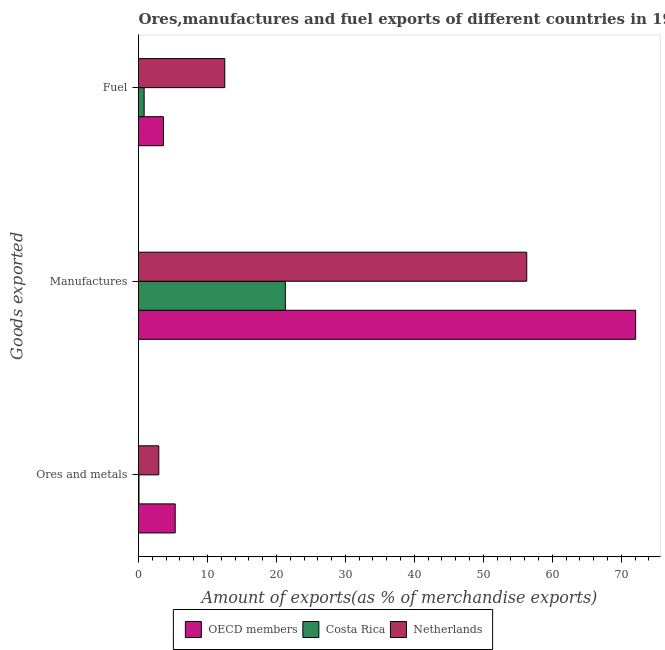How many groups of bars are there?
Offer a very short reply. 3. Are the number of bars on each tick of the Y-axis equal?
Keep it short and to the point. Yes. How many bars are there on the 3rd tick from the top?
Your response must be concise. 3. How many bars are there on the 1st tick from the bottom?
Your answer should be very brief. 3. What is the label of the 1st group of bars from the top?
Make the answer very short. Fuel. What is the percentage of ores and metals exports in Costa Rica?
Ensure brevity in your answer.  0.07. Across all countries, what is the maximum percentage of fuel exports?
Make the answer very short. 12.51. Across all countries, what is the minimum percentage of manufactures exports?
Keep it short and to the point. 21.29. In which country was the percentage of fuel exports minimum?
Your answer should be very brief. Costa Rica. What is the total percentage of manufactures exports in the graph?
Ensure brevity in your answer.  149.67. What is the difference between the percentage of fuel exports in Netherlands and that in Costa Rica?
Keep it short and to the point. 11.69. What is the difference between the percentage of fuel exports in Netherlands and the percentage of manufactures exports in Costa Rica?
Offer a very short reply. -8.78. What is the average percentage of manufactures exports per country?
Offer a terse response. 49.89. What is the difference between the percentage of manufactures exports and percentage of fuel exports in Netherlands?
Make the answer very short. 43.79. What is the ratio of the percentage of manufactures exports in OECD members to that in Netherlands?
Ensure brevity in your answer.  1.28. Is the difference between the percentage of fuel exports in Netherlands and Costa Rica greater than the difference between the percentage of manufactures exports in Netherlands and Costa Rica?
Your answer should be compact. No. What is the difference between the highest and the second highest percentage of fuel exports?
Offer a terse response. 8.9. What is the difference between the highest and the lowest percentage of fuel exports?
Offer a terse response. 11.69. What does the 3rd bar from the bottom in Manufactures represents?
Your answer should be compact. Netherlands. Is it the case that in every country, the sum of the percentage of ores and metals exports and percentage of manufactures exports is greater than the percentage of fuel exports?
Offer a terse response. Yes. Are all the bars in the graph horizontal?
Offer a very short reply. Yes. How many countries are there in the graph?
Make the answer very short. 3. Does the graph contain grids?
Give a very brief answer. No. How are the legend labels stacked?
Keep it short and to the point. Horizontal. What is the title of the graph?
Offer a terse response. Ores,manufactures and fuel exports of different countries in 1971. What is the label or title of the X-axis?
Provide a succinct answer. Amount of exports(as % of merchandise exports). What is the label or title of the Y-axis?
Ensure brevity in your answer.  Goods exported. What is the Amount of exports(as % of merchandise exports) of OECD members in Ores and metals?
Your response must be concise. 5.32. What is the Amount of exports(as % of merchandise exports) of Costa Rica in Ores and metals?
Give a very brief answer. 0.07. What is the Amount of exports(as % of merchandise exports) in Netherlands in Ores and metals?
Provide a succinct answer. 2.94. What is the Amount of exports(as % of merchandise exports) of OECD members in Manufactures?
Offer a very short reply. 72.08. What is the Amount of exports(as % of merchandise exports) in Costa Rica in Manufactures?
Keep it short and to the point. 21.29. What is the Amount of exports(as % of merchandise exports) of Netherlands in Manufactures?
Offer a very short reply. 56.29. What is the Amount of exports(as % of merchandise exports) in OECD members in Fuel?
Make the answer very short. 3.61. What is the Amount of exports(as % of merchandise exports) of Costa Rica in Fuel?
Provide a succinct answer. 0.82. What is the Amount of exports(as % of merchandise exports) of Netherlands in Fuel?
Make the answer very short. 12.51. Across all Goods exported, what is the maximum Amount of exports(as % of merchandise exports) of OECD members?
Provide a succinct answer. 72.08. Across all Goods exported, what is the maximum Amount of exports(as % of merchandise exports) in Costa Rica?
Your answer should be compact. 21.29. Across all Goods exported, what is the maximum Amount of exports(as % of merchandise exports) in Netherlands?
Provide a succinct answer. 56.29. Across all Goods exported, what is the minimum Amount of exports(as % of merchandise exports) in OECD members?
Your answer should be very brief. 3.61. Across all Goods exported, what is the minimum Amount of exports(as % of merchandise exports) in Costa Rica?
Give a very brief answer. 0.07. Across all Goods exported, what is the minimum Amount of exports(as % of merchandise exports) of Netherlands?
Keep it short and to the point. 2.94. What is the total Amount of exports(as % of merchandise exports) of OECD members in the graph?
Offer a terse response. 81.01. What is the total Amount of exports(as % of merchandise exports) in Costa Rica in the graph?
Your answer should be compact. 22.17. What is the total Amount of exports(as % of merchandise exports) in Netherlands in the graph?
Your response must be concise. 71.74. What is the difference between the Amount of exports(as % of merchandise exports) in OECD members in Ores and metals and that in Manufactures?
Your answer should be very brief. -66.76. What is the difference between the Amount of exports(as % of merchandise exports) of Costa Rica in Ores and metals and that in Manufactures?
Ensure brevity in your answer.  -21.22. What is the difference between the Amount of exports(as % of merchandise exports) of Netherlands in Ores and metals and that in Manufactures?
Your answer should be compact. -53.35. What is the difference between the Amount of exports(as % of merchandise exports) of OECD members in Ores and metals and that in Fuel?
Ensure brevity in your answer.  1.71. What is the difference between the Amount of exports(as % of merchandise exports) of Costa Rica in Ores and metals and that in Fuel?
Ensure brevity in your answer.  -0.75. What is the difference between the Amount of exports(as % of merchandise exports) in Netherlands in Ores and metals and that in Fuel?
Your answer should be very brief. -9.56. What is the difference between the Amount of exports(as % of merchandise exports) in OECD members in Manufactures and that in Fuel?
Offer a terse response. 68.47. What is the difference between the Amount of exports(as % of merchandise exports) of Costa Rica in Manufactures and that in Fuel?
Provide a succinct answer. 20.47. What is the difference between the Amount of exports(as % of merchandise exports) in Netherlands in Manufactures and that in Fuel?
Keep it short and to the point. 43.79. What is the difference between the Amount of exports(as % of merchandise exports) in OECD members in Ores and metals and the Amount of exports(as % of merchandise exports) in Costa Rica in Manufactures?
Make the answer very short. -15.97. What is the difference between the Amount of exports(as % of merchandise exports) in OECD members in Ores and metals and the Amount of exports(as % of merchandise exports) in Netherlands in Manufactures?
Give a very brief answer. -50.97. What is the difference between the Amount of exports(as % of merchandise exports) of Costa Rica in Ores and metals and the Amount of exports(as % of merchandise exports) of Netherlands in Manufactures?
Your answer should be very brief. -56.23. What is the difference between the Amount of exports(as % of merchandise exports) of OECD members in Ores and metals and the Amount of exports(as % of merchandise exports) of Costa Rica in Fuel?
Keep it short and to the point. 4.5. What is the difference between the Amount of exports(as % of merchandise exports) of OECD members in Ores and metals and the Amount of exports(as % of merchandise exports) of Netherlands in Fuel?
Provide a succinct answer. -7.19. What is the difference between the Amount of exports(as % of merchandise exports) of Costa Rica in Ores and metals and the Amount of exports(as % of merchandise exports) of Netherlands in Fuel?
Offer a terse response. -12.44. What is the difference between the Amount of exports(as % of merchandise exports) in OECD members in Manufactures and the Amount of exports(as % of merchandise exports) in Costa Rica in Fuel?
Offer a terse response. 71.27. What is the difference between the Amount of exports(as % of merchandise exports) of OECD members in Manufactures and the Amount of exports(as % of merchandise exports) of Netherlands in Fuel?
Give a very brief answer. 59.58. What is the difference between the Amount of exports(as % of merchandise exports) in Costa Rica in Manufactures and the Amount of exports(as % of merchandise exports) in Netherlands in Fuel?
Provide a short and direct response. 8.78. What is the average Amount of exports(as % of merchandise exports) in OECD members per Goods exported?
Provide a succinct answer. 27. What is the average Amount of exports(as % of merchandise exports) of Costa Rica per Goods exported?
Offer a very short reply. 7.39. What is the average Amount of exports(as % of merchandise exports) of Netherlands per Goods exported?
Your answer should be compact. 23.91. What is the difference between the Amount of exports(as % of merchandise exports) in OECD members and Amount of exports(as % of merchandise exports) in Costa Rica in Ores and metals?
Your response must be concise. 5.25. What is the difference between the Amount of exports(as % of merchandise exports) in OECD members and Amount of exports(as % of merchandise exports) in Netherlands in Ores and metals?
Ensure brevity in your answer.  2.38. What is the difference between the Amount of exports(as % of merchandise exports) of Costa Rica and Amount of exports(as % of merchandise exports) of Netherlands in Ores and metals?
Your answer should be very brief. -2.88. What is the difference between the Amount of exports(as % of merchandise exports) in OECD members and Amount of exports(as % of merchandise exports) in Costa Rica in Manufactures?
Provide a succinct answer. 50.79. What is the difference between the Amount of exports(as % of merchandise exports) of OECD members and Amount of exports(as % of merchandise exports) of Netherlands in Manufactures?
Provide a succinct answer. 15.79. What is the difference between the Amount of exports(as % of merchandise exports) of Costa Rica and Amount of exports(as % of merchandise exports) of Netherlands in Manufactures?
Offer a very short reply. -35. What is the difference between the Amount of exports(as % of merchandise exports) in OECD members and Amount of exports(as % of merchandise exports) in Costa Rica in Fuel?
Keep it short and to the point. 2.79. What is the difference between the Amount of exports(as % of merchandise exports) of OECD members and Amount of exports(as % of merchandise exports) of Netherlands in Fuel?
Provide a short and direct response. -8.9. What is the difference between the Amount of exports(as % of merchandise exports) in Costa Rica and Amount of exports(as % of merchandise exports) in Netherlands in Fuel?
Your response must be concise. -11.69. What is the ratio of the Amount of exports(as % of merchandise exports) in OECD members in Ores and metals to that in Manufactures?
Your answer should be very brief. 0.07. What is the ratio of the Amount of exports(as % of merchandise exports) in Costa Rica in Ores and metals to that in Manufactures?
Make the answer very short. 0. What is the ratio of the Amount of exports(as % of merchandise exports) in Netherlands in Ores and metals to that in Manufactures?
Ensure brevity in your answer.  0.05. What is the ratio of the Amount of exports(as % of merchandise exports) in OECD members in Ores and metals to that in Fuel?
Provide a succinct answer. 1.47. What is the ratio of the Amount of exports(as % of merchandise exports) in Costa Rica in Ores and metals to that in Fuel?
Make the answer very short. 0.08. What is the ratio of the Amount of exports(as % of merchandise exports) of Netherlands in Ores and metals to that in Fuel?
Your answer should be compact. 0.24. What is the ratio of the Amount of exports(as % of merchandise exports) of OECD members in Manufactures to that in Fuel?
Provide a succinct answer. 19.97. What is the ratio of the Amount of exports(as % of merchandise exports) of Costa Rica in Manufactures to that in Fuel?
Keep it short and to the point. 26.04. What is the ratio of the Amount of exports(as % of merchandise exports) of Netherlands in Manufactures to that in Fuel?
Ensure brevity in your answer.  4.5. What is the difference between the highest and the second highest Amount of exports(as % of merchandise exports) in OECD members?
Provide a short and direct response. 66.76. What is the difference between the highest and the second highest Amount of exports(as % of merchandise exports) in Costa Rica?
Your answer should be compact. 20.47. What is the difference between the highest and the second highest Amount of exports(as % of merchandise exports) of Netherlands?
Your answer should be compact. 43.79. What is the difference between the highest and the lowest Amount of exports(as % of merchandise exports) of OECD members?
Make the answer very short. 68.47. What is the difference between the highest and the lowest Amount of exports(as % of merchandise exports) of Costa Rica?
Ensure brevity in your answer.  21.22. What is the difference between the highest and the lowest Amount of exports(as % of merchandise exports) of Netherlands?
Ensure brevity in your answer.  53.35. 